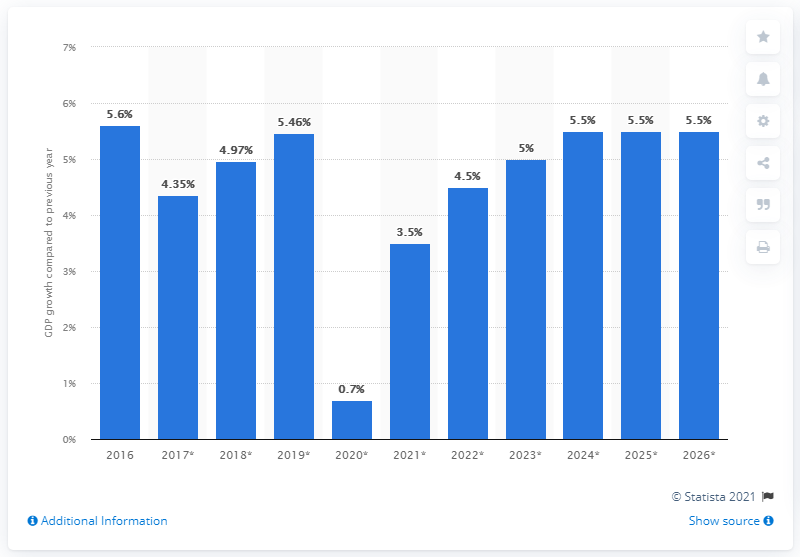Highlight a few significant elements in this photo. Togo's real GDP grew by 5.6% in 2016. 